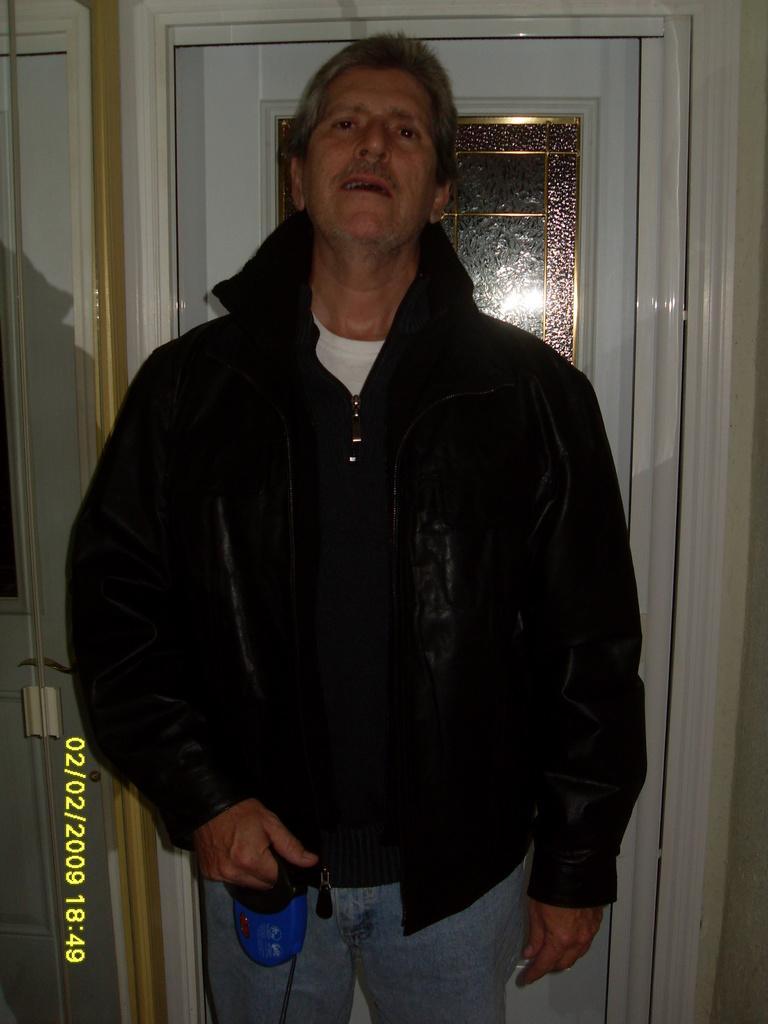In one or two sentences, can you explain what this image depicts? There is a person holding something in the hand. He is wearing a black jacket. In the background there is a door. 